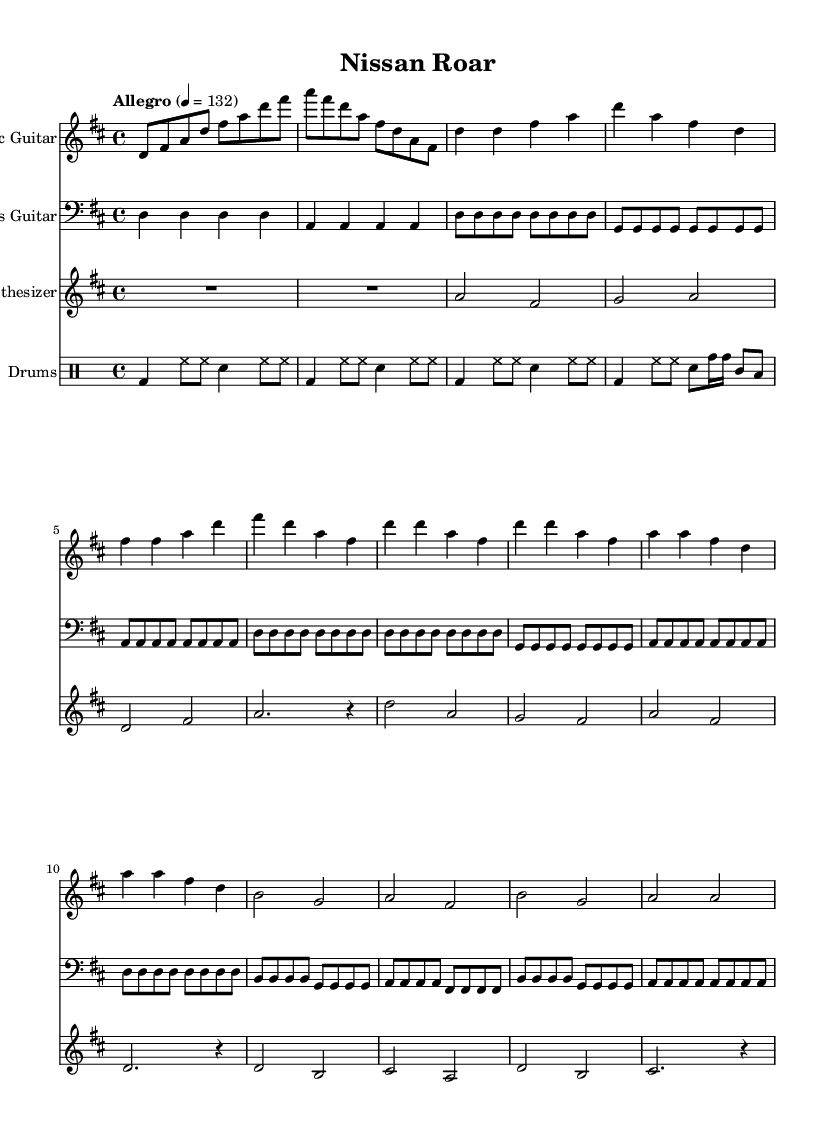What is the key signature of this music? The key signature is indicated by the sharps or flats at the beginning of the staff. This sheet music shows two sharps (F# and C#), which indicates that the key is D major.
Answer: D major What is the time signature of this music? The time signature is found at the beginning of the staff. It is shown as 4/4, meaning there are four beats in a measure and each beat is a quarter note.
Answer: 4/4 What is the tempo marking for this piece? The tempo marking is found in the global section, specifying the speed of the piece. It is indicated as "Allegro" with a metronome marking of 132 beats per minute.
Answer: Allegro, 132 How many measures are in the guitar section? Counting the measures in the guitar part, we find that there is a total of 20 measures throughout the piece, including intro, verse, chorus, and bridge sections.
Answer: 20 What instruments are used in this composition? The instruments can be found at the beginning of each staff in the sheet music. In this piece, there are four instruments: Electric Guitar, Bass Guitar, Synthesizer, and Drums.
Answer: Electric Guitar, Bass Guitar, Synthesizer, Drums Which part features the drum fill? The drum fill occurs in the "With fill" section of the drums part, where specific notes like toms are added after the basic beat. It is clear from the drummode section that the fill starts in the second measure of the fill section.
Answer: Drum fill 